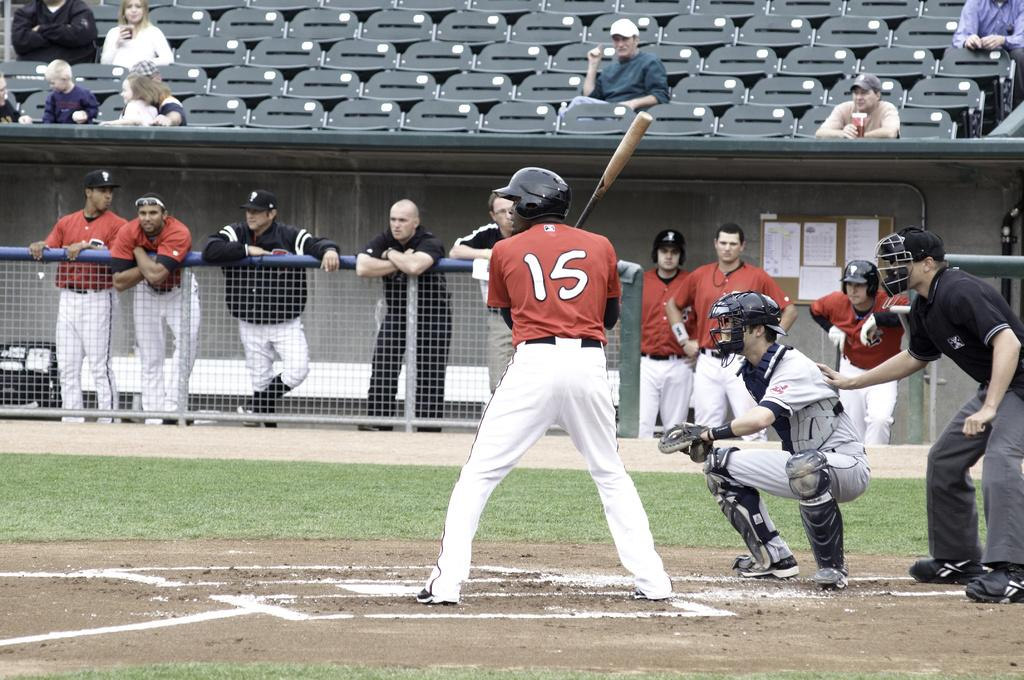<image>
Give a short and clear explanation of the subsequent image. Number 15 digs into the box and prepares to take his at bat. 